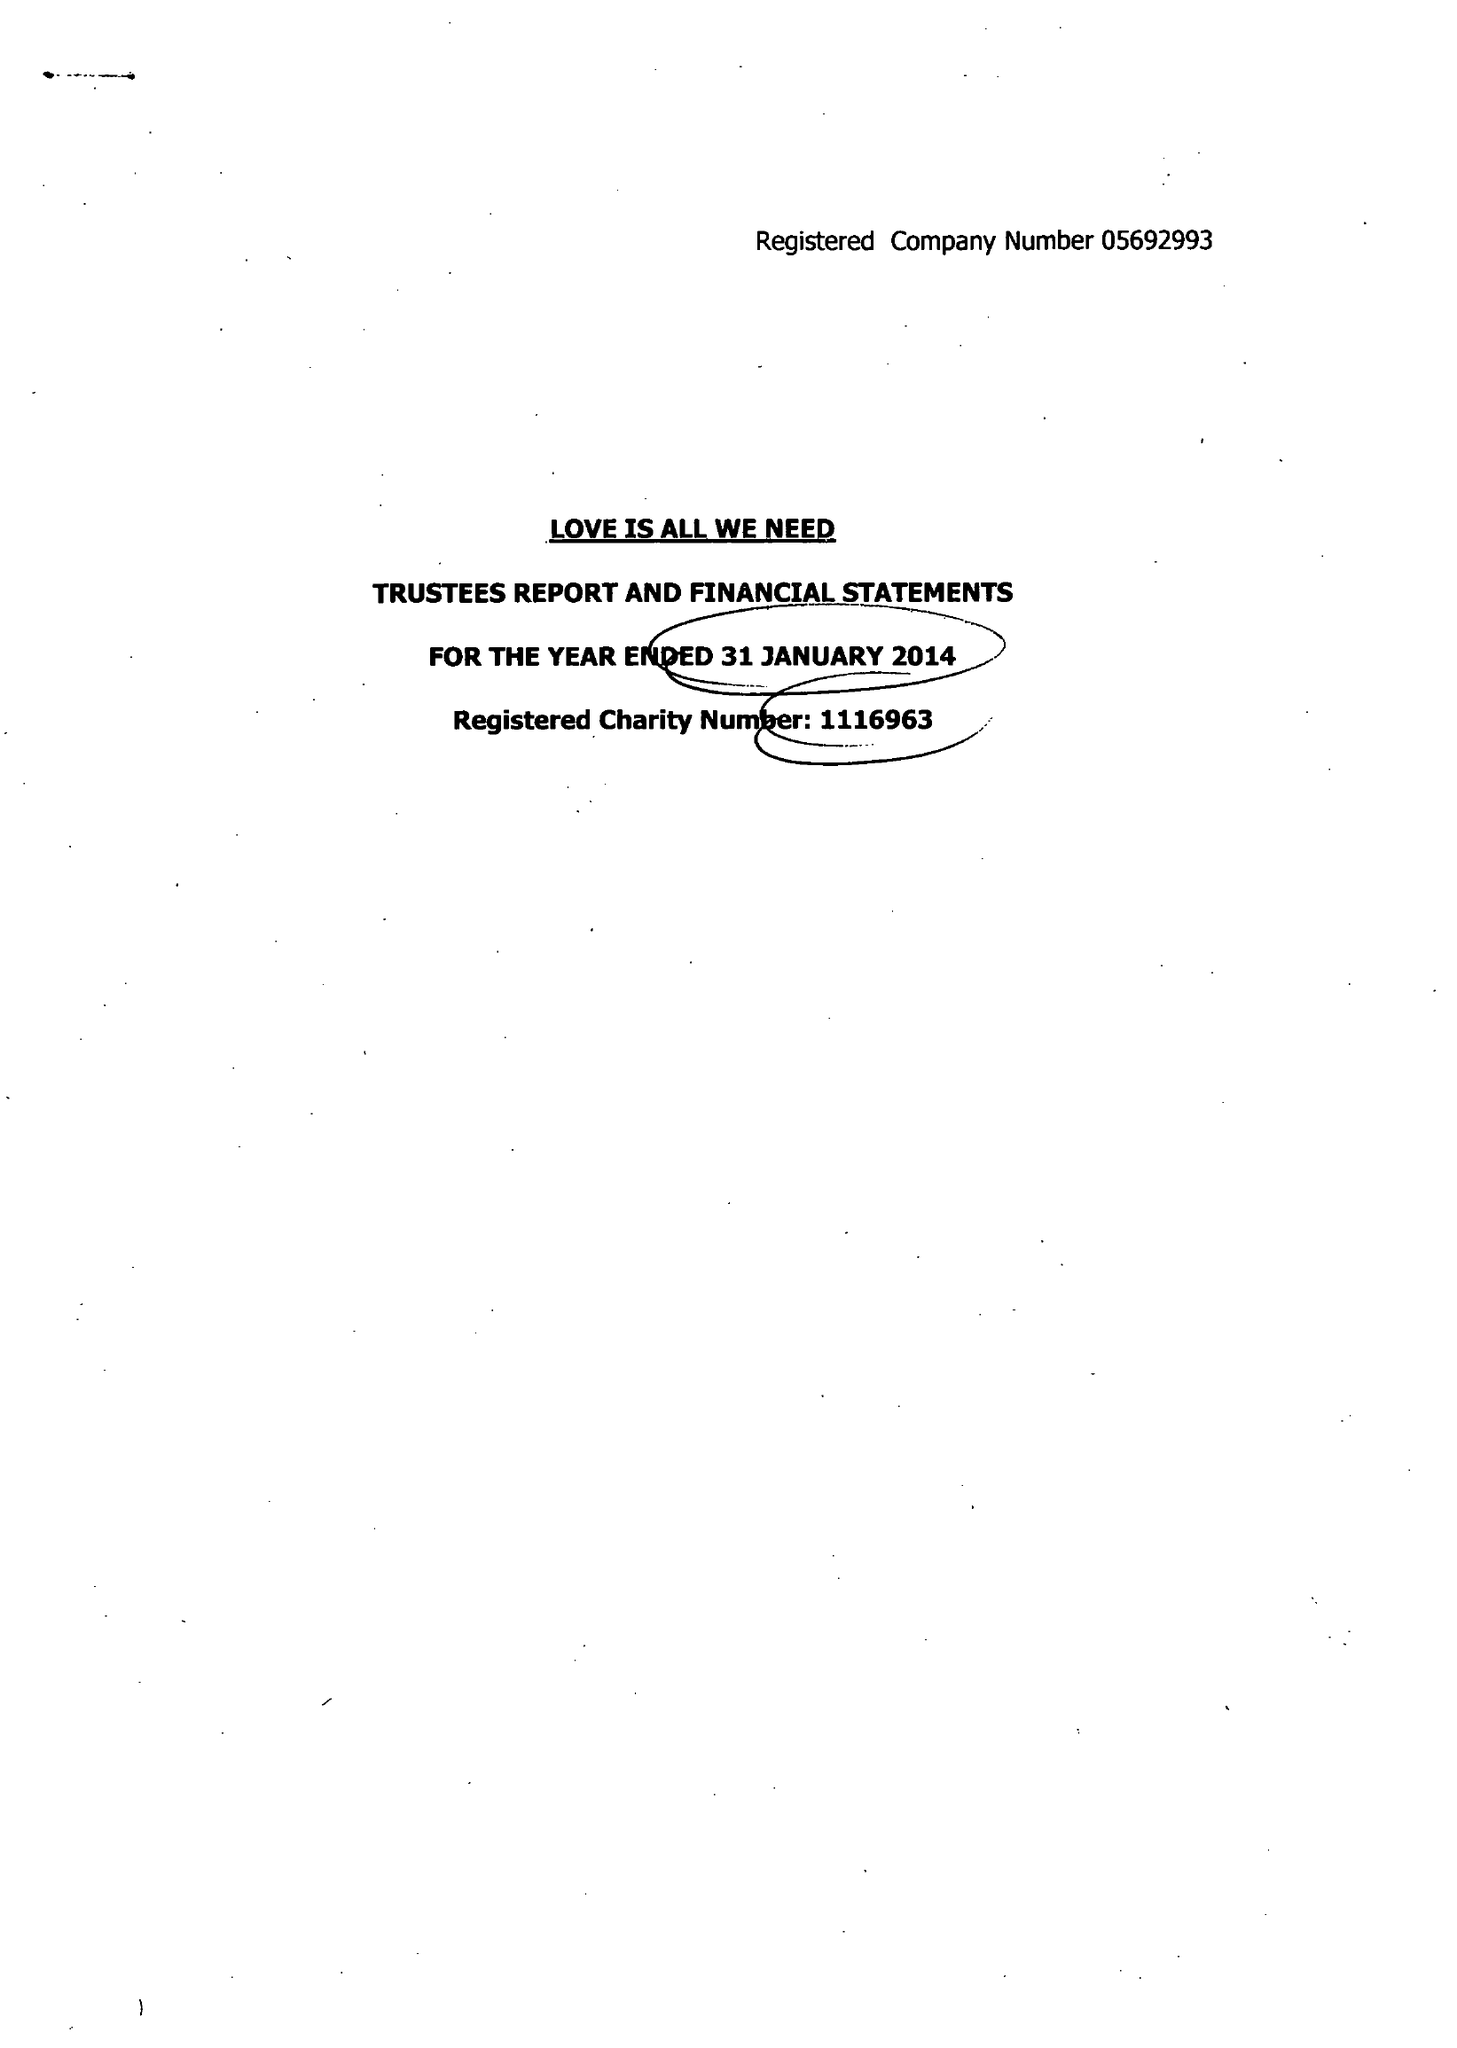What is the value for the report_date?
Answer the question using a single word or phrase. 2014-01-31 